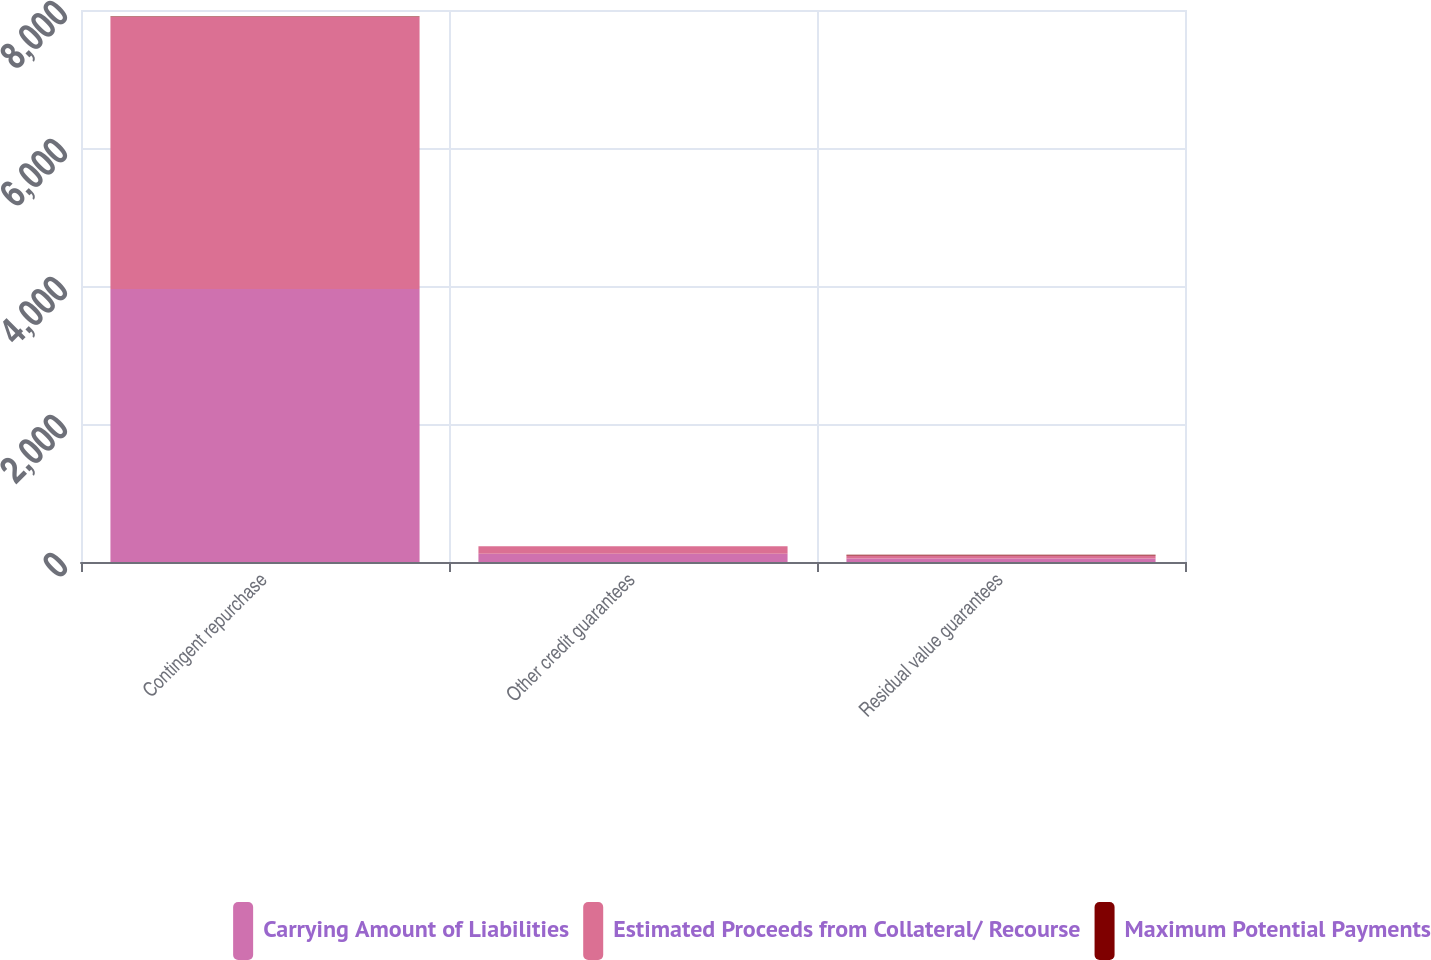Convert chart to OTSL. <chart><loc_0><loc_0><loc_500><loc_500><stacked_bar_chart><ecel><fcel>Contingent repurchase<fcel>Other credit guarantees<fcel>Residual value guarantees<nl><fcel>Carrying Amount of Liabilities<fcel>3958<fcel>119<fcel>51<nl><fcel>Estimated Proceeds from Collateral/ Recourse<fcel>3940<fcel>109<fcel>44<nl><fcel>Maximum Potential Payments<fcel>7<fcel>2<fcel>10<nl></chart> 